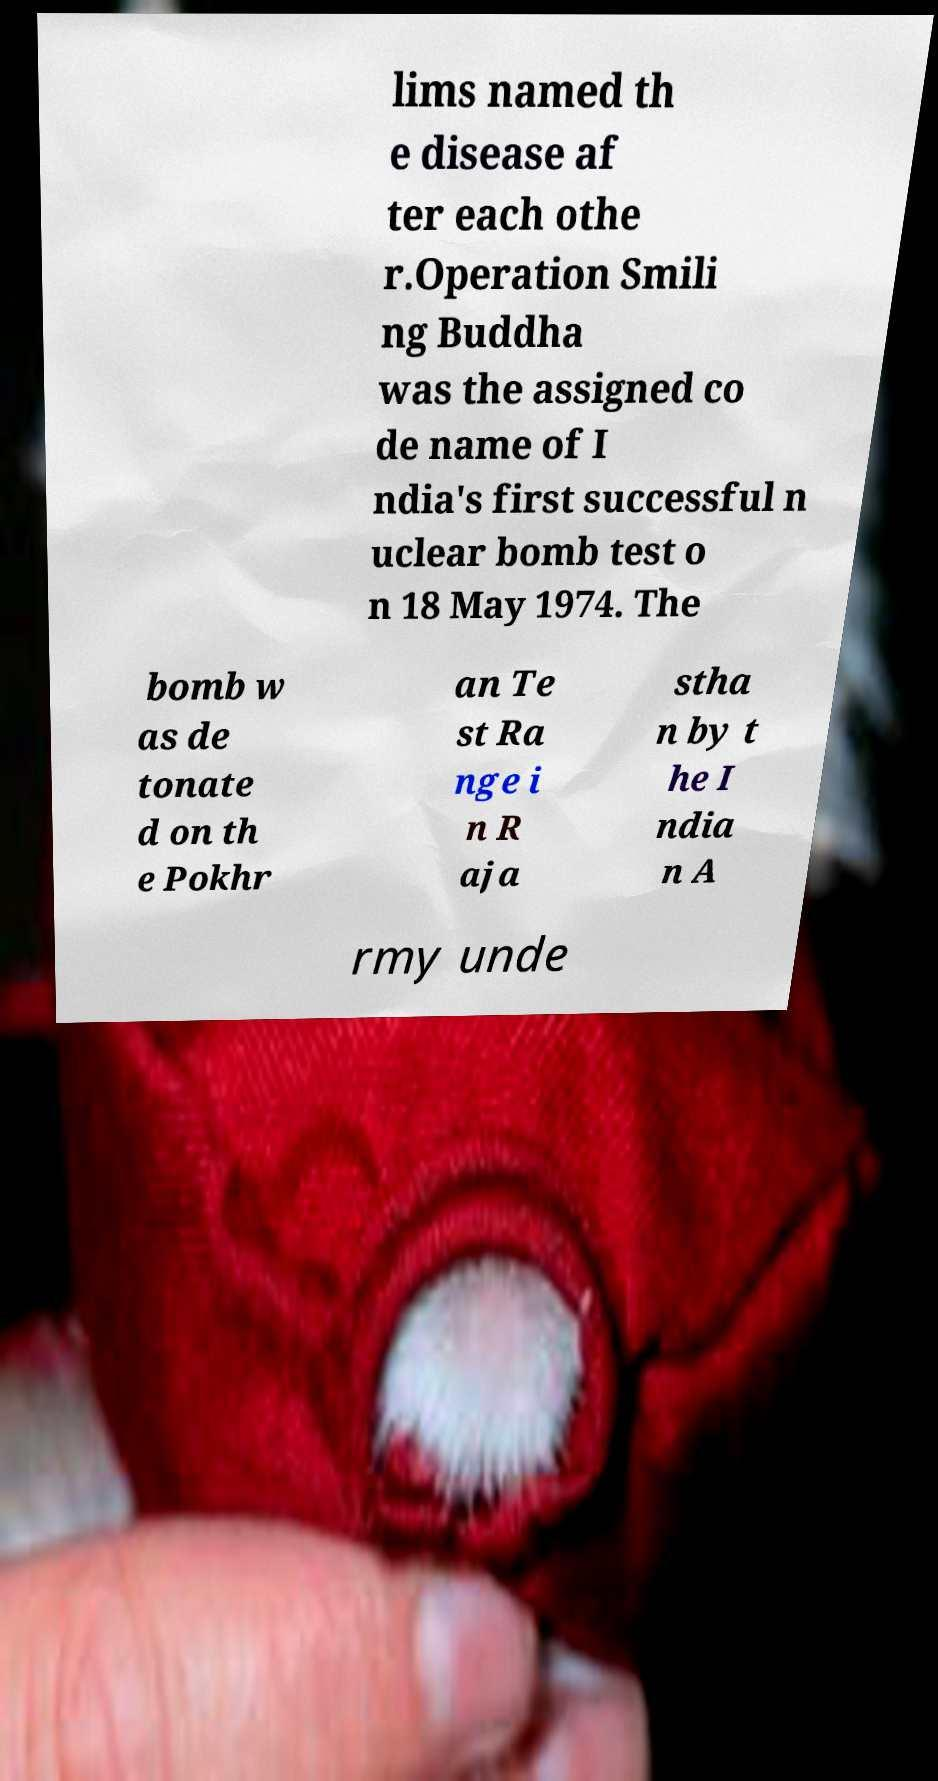For documentation purposes, I need the text within this image transcribed. Could you provide that? lims named th e disease af ter each othe r.Operation Smili ng Buddha was the assigned co de name of I ndia's first successful n uclear bomb test o n 18 May 1974. The bomb w as de tonate d on th e Pokhr an Te st Ra nge i n R aja stha n by t he I ndia n A rmy unde 